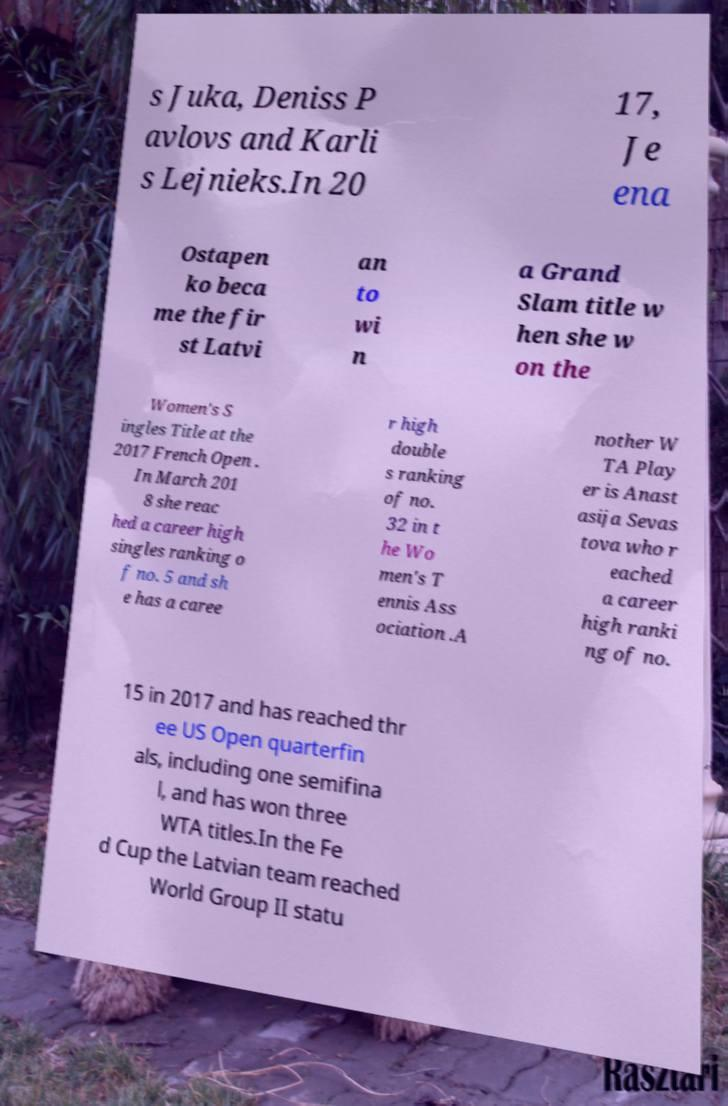What messages or text are displayed in this image? I need them in a readable, typed format. s Juka, Deniss P avlovs and Karli s Lejnieks.In 20 17, Je ena Ostapen ko beca me the fir st Latvi an to wi n a Grand Slam title w hen she w on the Women's S ingles Title at the 2017 French Open . In March 201 8 she reac hed a career high singles ranking o f no. 5 and sh e has a caree r high double s ranking of no. 32 in t he Wo men's T ennis Ass ociation .A nother W TA Play er is Anast asija Sevas tova who r eached a career high ranki ng of no. 15 in 2017 and has reached thr ee US Open quarterfin als, including one semifina l, and has won three WTA titles.In the Fe d Cup the Latvian team reached World Group II statu 